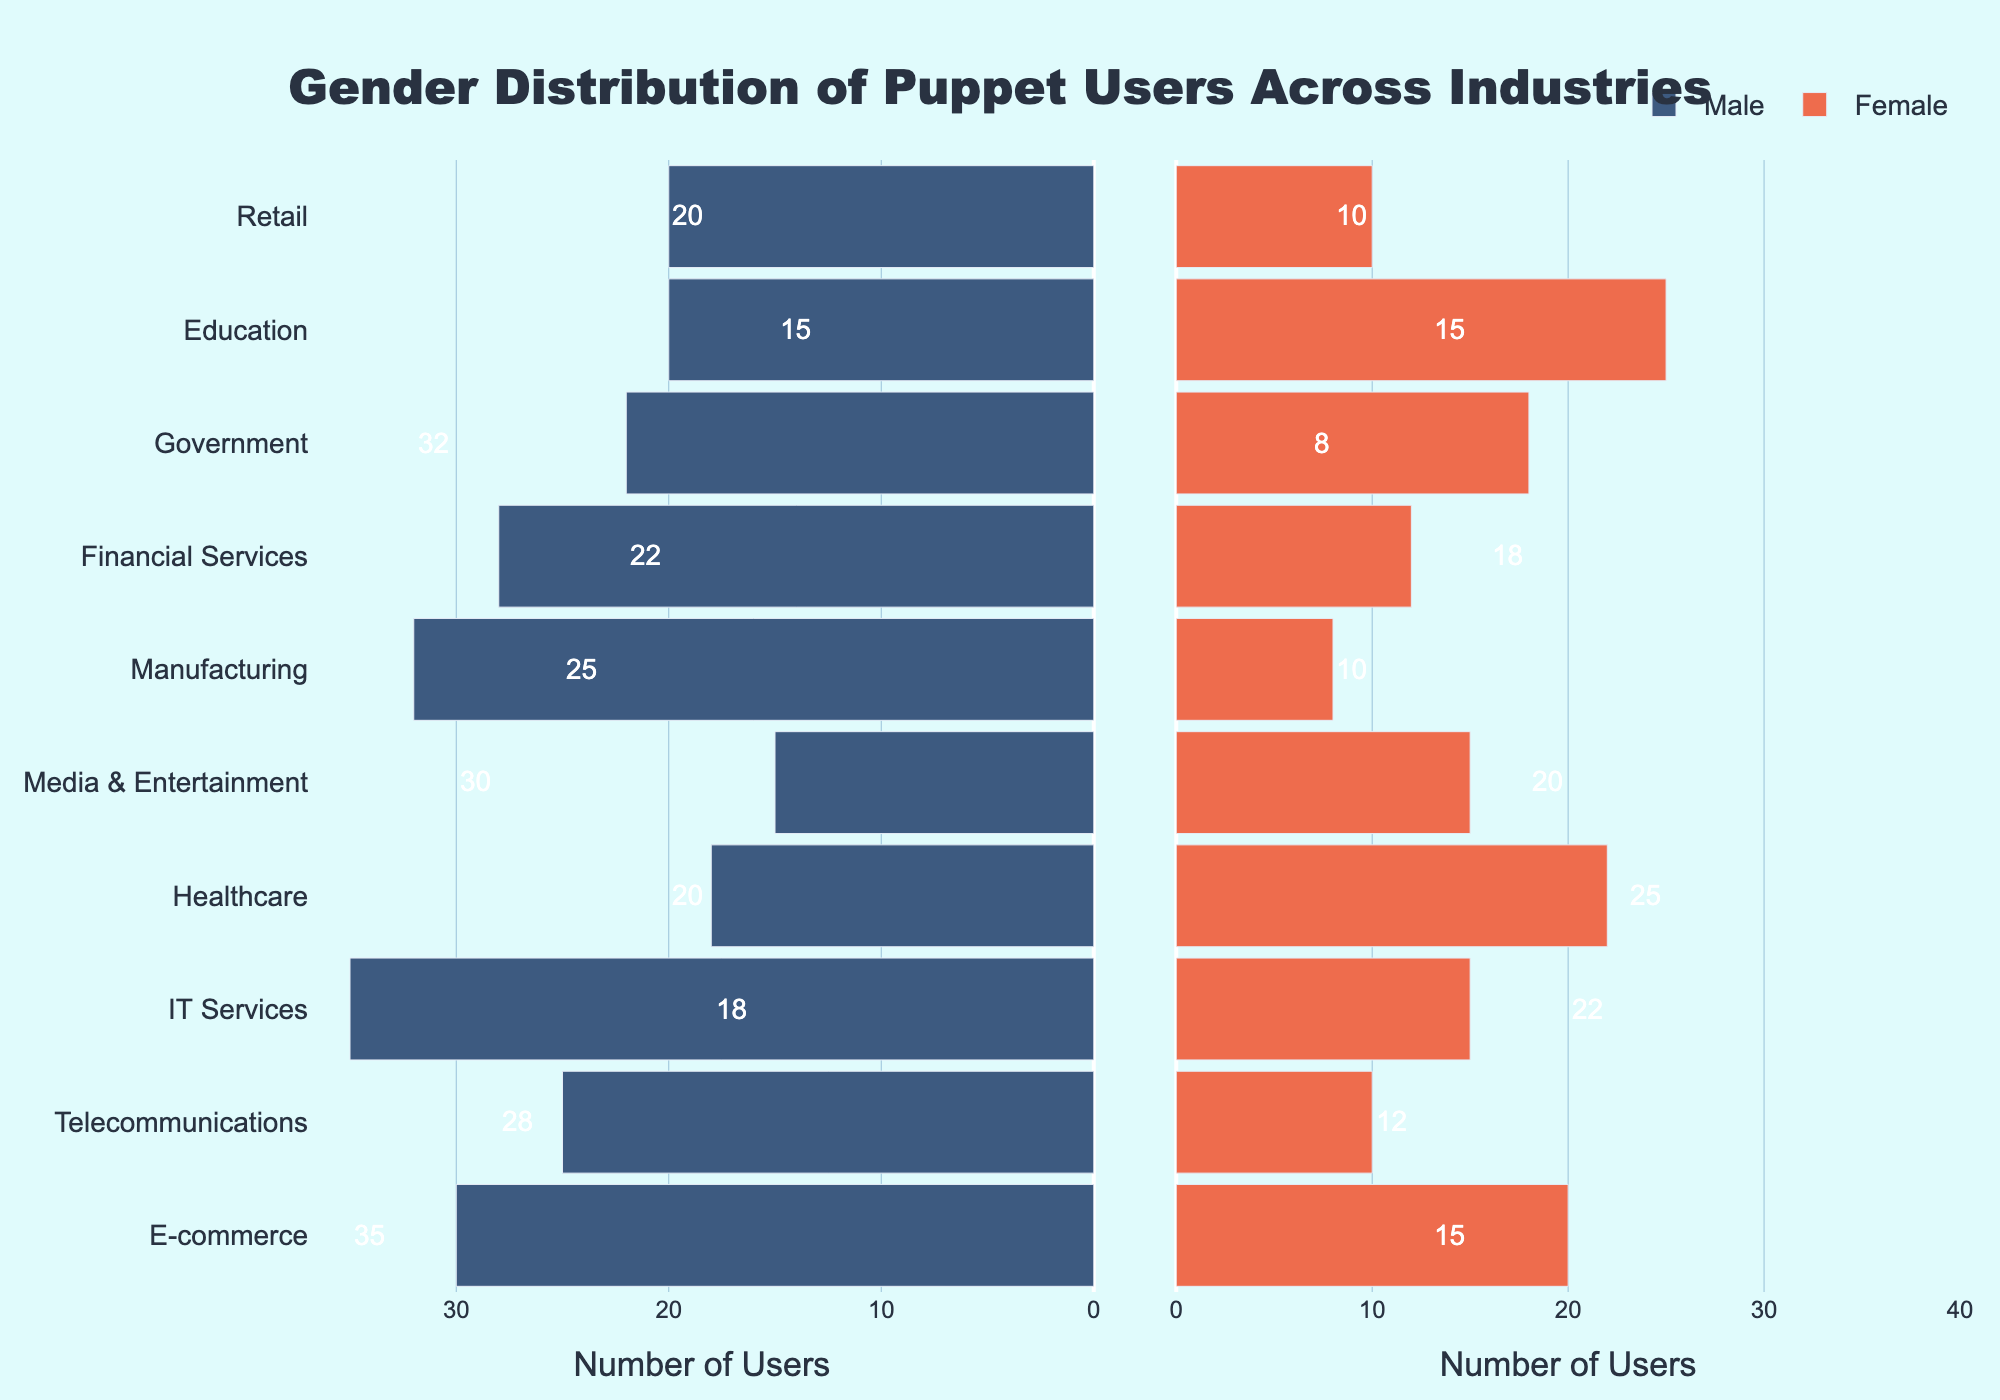What is the title of the figure? The title is usually displayed at the top center of the figure. In this case, the title is "Gender Distribution of Puppet Users Across Industries".
Answer: Gender Distribution of Puppet Users Across Industries How many female Puppet users are in the Healthcare industry? Look at the female bar for the Healthcare industry on the right side of the population pyramid. The length of the bar and the annotation on it indicate the number of female users.
Answer: 22 Which industry has the highest number of male Puppet users? Compare the lengths of the male bars on the left side of the figure. The industry with the longest bar will have the highest number of male users.
Answer: IT Services How does the number of male Puppet users compare to female Puppet users in the Education industry? Look at the male and female bars for the Education industry. The lengths of the bars and the annotations on them indicate the number of users.
Answer: There are 20 male users and 25 female users Which industry has a nearly balanced number of male and female Puppet users? Look for industries where the lengths of male and female bars are approximately equal. In this case, the Media & Entertainment industry has equal lengths for both bars.
Answer: Media & Entertainment What is the total number of Puppet users in the Manufacturing industry? Sum the male and female users in the Manufacturing industry. The male users are 32 and the female users are 8.
Answer: 40 In which industry is the gender disparity for Puppet users the largest? Compare the difference in lengths between the male and female bars across industries. The Manufacturing industry has the largest difference.
Answer: Manufacturing On average, how many female Puppet users are there across all industries? Sum the female users across all industries and then divide by the number of industries. The total sum is 155 and there are 10 industries.
Answer: 15.5 Which industry has the second-highest total number of Puppet users? Calculate the sum of male and female users for each industry and then identify the second-highest. IT Services is the highest (50), and E-commerce is the second with a total of 50 users (30 males and 20 females).
Answer: E-commerce What is the least represented industry for male Puppet users? Look for the male bar with the shortest length. Media & Entertainment has the shortest male bar with 15 users.
Answer: Media & Entertainment 